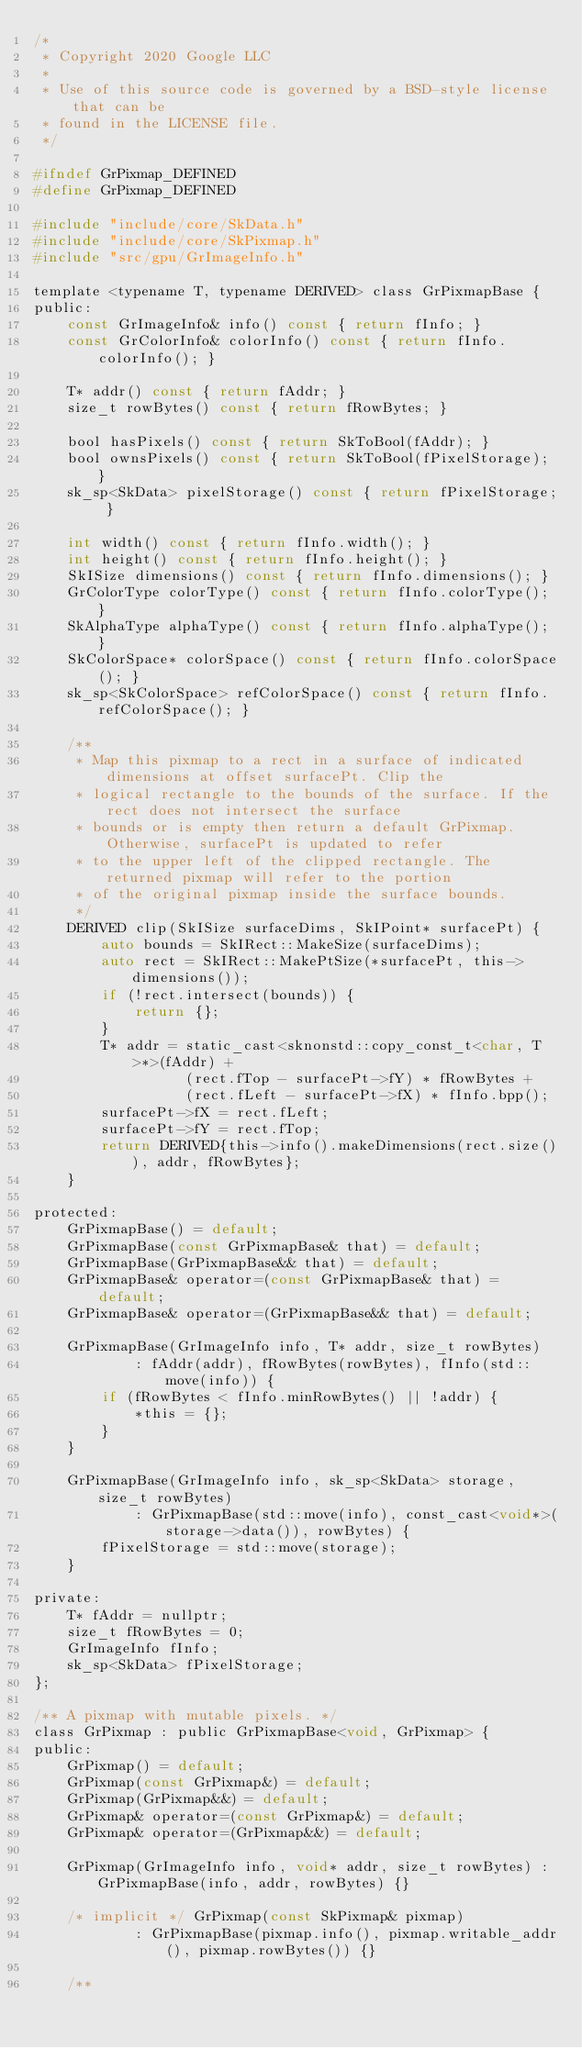<code> <loc_0><loc_0><loc_500><loc_500><_C_>/*
 * Copyright 2020 Google LLC
 *
 * Use of this source code is governed by a BSD-style license that can be
 * found in the LICENSE file.
 */

#ifndef GrPixmap_DEFINED
#define GrPixmap_DEFINED

#include "include/core/SkData.h"
#include "include/core/SkPixmap.h"
#include "src/gpu/GrImageInfo.h"

template <typename T, typename DERIVED> class GrPixmapBase {
public:
    const GrImageInfo& info() const { return fInfo; }
    const GrColorInfo& colorInfo() const { return fInfo.colorInfo(); }

    T* addr() const { return fAddr; }
    size_t rowBytes() const { return fRowBytes; }

    bool hasPixels() const { return SkToBool(fAddr); }
    bool ownsPixels() const { return SkToBool(fPixelStorage); }
    sk_sp<SkData> pixelStorage() const { return fPixelStorage; }

    int width() const { return fInfo.width(); }
    int height() const { return fInfo.height(); }
    SkISize dimensions() const { return fInfo.dimensions(); }
    GrColorType colorType() const { return fInfo.colorType(); }
    SkAlphaType alphaType() const { return fInfo.alphaType(); }
    SkColorSpace* colorSpace() const { return fInfo.colorSpace(); }
    sk_sp<SkColorSpace> refColorSpace() const { return fInfo.refColorSpace(); }

    /**
     * Map this pixmap to a rect in a surface of indicated dimensions at offset surfacePt. Clip the
     * logical rectangle to the bounds of the surface. If the rect does not intersect the surface
     * bounds or is empty then return a default GrPixmap. Otherwise, surfacePt is updated to refer
     * to the upper left of the clipped rectangle. The returned pixmap will refer to the portion
     * of the original pixmap inside the surface bounds.
     */
    DERIVED clip(SkISize surfaceDims, SkIPoint* surfacePt) {
        auto bounds = SkIRect::MakeSize(surfaceDims);
        auto rect = SkIRect::MakePtSize(*surfacePt, this->dimensions());
        if (!rect.intersect(bounds)) {
            return {};
        }
        T* addr = static_cast<sknonstd::copy_const_t<char, T>*>(fAddr) +
                  (rect.fTop - surfacePt->fY) * fRowBytes +
                  (rect.fLeft - surfacePt->fX) * fInfo.bpp();
        surfacePt->fX = rect.fLeft;
        surfacePt->fY = rect.fTop;
        return DERIVED{this->info().makeDimensions(rect.size()), addr, fRowBytes};
    }

protected:
    GrPixmapBase() = default;
    GrPixmapBase(const GrPixmapBase& that) = default;
    GrPixmapBase(GrPixmapBase&& that) = default;
    GrPixmapBase& operator=(const GrPixmapBase& that) = default;
    GrPixmapBase& operator=(GrPixmapBase&& that) = default;

    GrPixmapBase(GrImageInfo info, T* addr, size_t rowBytes)
            : fAddr(addr), fRowBytes(rowBytes), fInfo(std::move(info)) {
        if (fRowBytes < fInfo.minRowBytes() || !addr) {
            *this = {};
        }
    }

    GrPixmapBase(GrImageInfo info, sk_sp<SkData> storage, size_t rowBytes)
            : GrPixmapBase(std::move(info), const_cast<void*>(storage->data()), rowBytes) {
        fPixelStorage = std::move(storage);
    }

private:
    T* fAddr = nullptr;
    size_t fRowBytes = 0;
    GrImageInfo fInfo;
    sk_sp<SkData> fPixelStorage;
};

/** A pixmap with mutable pixels. */
class GrPixmap : public GrPixmapBase<void, GrPixmap> {
public:
    GrPixmap() = default;
    GrPixmap(const GrPixmap&) = default;
    GrPixmap(GrPixmap&&) = default;
    GrPixmap& operator=(const GrPixmap&) = default;
    GrPixmap& operator=(GrPixmap&&) = default;

    GrPixmap(GrImageInfo info, void* addr, size_t rowBytes) : GrPixmapBase(info, addr, rowBytes) {}

    /* implicit */ GrPixmap(const SkPixmap& pixmap)
            : GrPixmapBase(pixmap.info(), pixmap.writable_addr(), pixmap.rowBytes()) {}

    /**</code> 